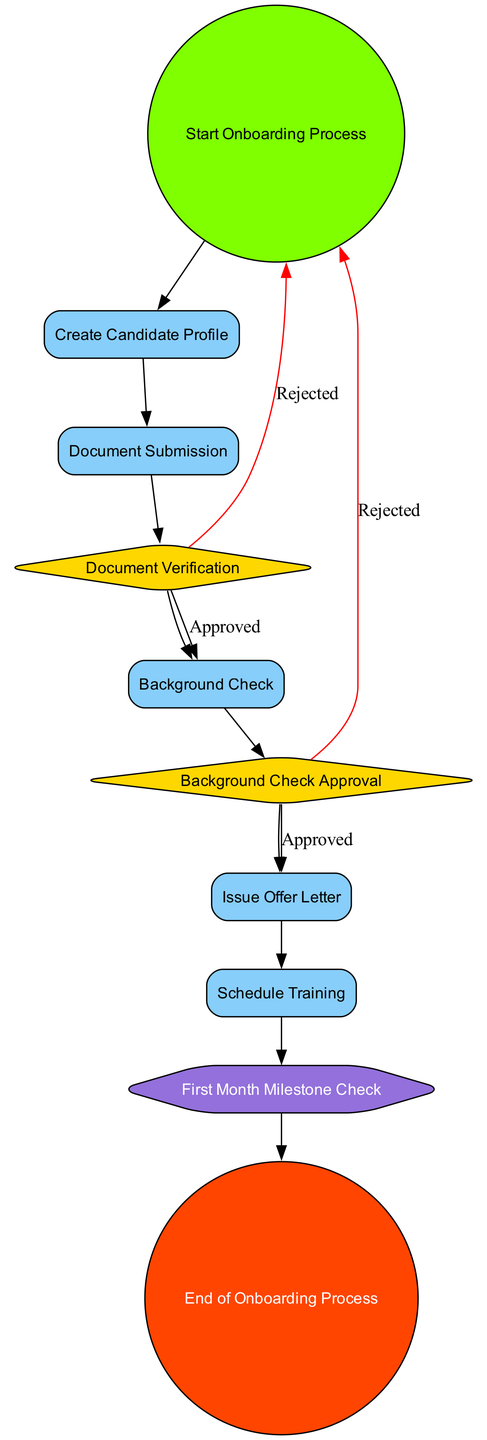What is the first step in the onboarding process? The diagram indicates that the onboarding process starts with the node labeled "Start Onboarding Process."
Answer: Start Onboarding Process How many decision nodes are present in the diagram? By reviewing the diagram, we see there are two decision nodes: "Document Verification" and "Background Check Approval." Counting them gives a total of two.
Answer: 2 What follows the "Document Submission" process? The sequence in the diagram shows that after "Document Submission," the next step is the "Document Verification" decision node.
Answer: Document Verification What is the milestone check in the onboarding workflow? The diagram identifies a specific milestone check labeled as "First Month Milestone Check," which is used to evaluate performance and engagement.
Answer: First Month Milestone Check What action is taken when the background check is approved? The flowchart specifies that if the background check is approved, the next action taken is to issue the "Offer Letter" to the candidate.
Answer: Issue Offer Letter What happens if the document verification is rejected? According to the diagram, if the document verification is rejected, the process loops back to the "Start Onboarding Process."
Answer: Start Onboarding Process How many processes are involved in the onboarding workflow? Analyzing the diagram, we find that there are five process nodes: "Create Candidate Profile," "Document Submission," "Background Check," "Issue Offer Letter," and "Schedule Training." Thus, there are five processes in total.
Answer: 5 What type of node is used for the end of the onboarding process? The diagram states that the end of the onboarding process is represented by an "endEvent" node labeled "End of Onboarding Process."
Answer: End of Onboarding Process What type of node is used to represent the training scheduling action? The action of scheduling training is depicted as a "process" node within the diagram, specifically labeled "Schedule Training."
Answer: process 